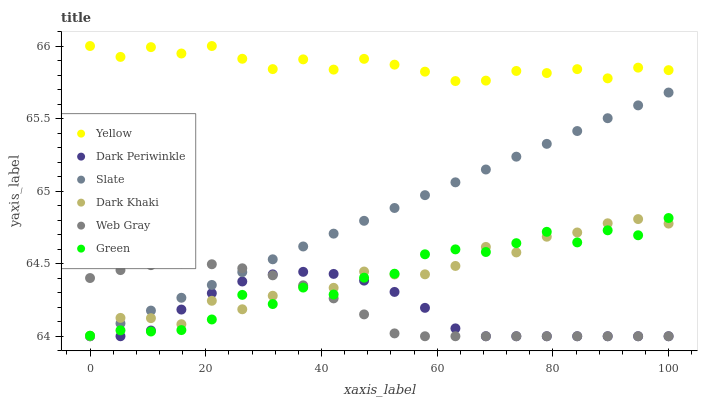Does Dark Periwinkle have the minimum area under the curve?
Answer yes or no. Yes. Does Yellow have the maximum area under the curve?
Answer yes or no. Yes. Does Slate have the minimum area under the curve?
Answer yes or no. No. Does Slate have the maximum area under the curve?
Answer yes or no. No. Is Slate the smoothest?
Answer yes or no. Yes. Is Green the roughest?
Answer yes or no. Yes. Is Yellow the smoothest?
Answer yes or no. No. Is Yellow the roughest?
Answer yes or no. No. Does Web Gray have the lowest value?
Answer yes or no. Yes. Does Yellow have the lowest value?
Answer yes or no. No. Does Yellow have the highest value?
Answer yes or no. Yes. Does Slate have the highest value?
Answer yes or no. No. Is Web Gray less than Yellow?
Answer yes or no. Yes. Is Yellow greater than Slate?
Answer yes or no. Yes. Does Green intersect Web Gray?
Answer yes or no. Yes. Is Green less than Web Gray?
Answer yes or no. No. Is Green greater than Web Gray?
Answer yes or no. No. Does Web Gray intersect Yellow?
Answer yes or no. No. 